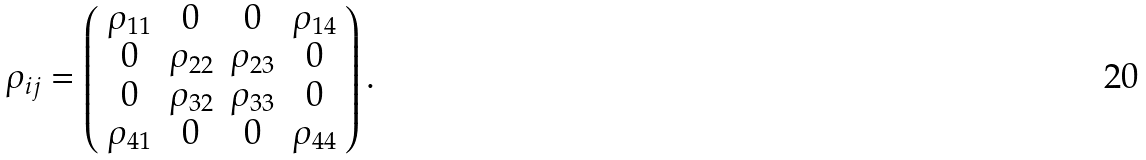<formula> <loc_0><loc_0><loc_500><loc_500>\rho _ { i j } = \left ( \begin{array} { c c c c } \rho _ { 1 1 } & 0 & 0 & \rho _ { 1 4 } \\ 0 & \rho _ { 2 2 } & \rho _ { 2 3 } & 0 \\ 0 & \rho _ { 3 2 } & \rho _ { 3 3 } & 0 \\ \rho _ { 4 1 } & 0 & 0 & \rho _ { 4 4 } \\ \end{array} \right ) .</formula> 